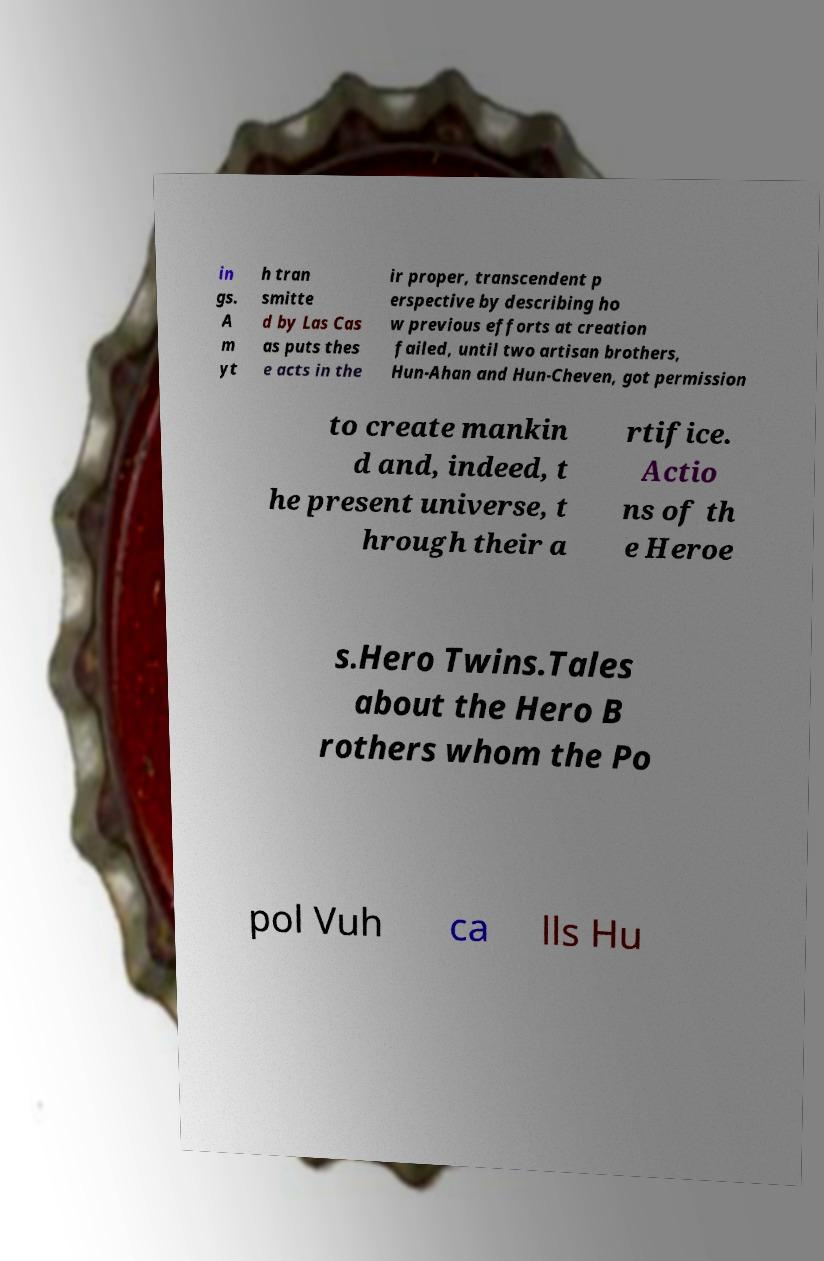Please identify and transcribe the text found in this image. in gs. A m yt h tran smitte d by Las Cas as puts thes e acts in the ir proper, transcendent p erspective by describing ho w previous efforts at creation failed, until two artisan brothers, Hun-Ahan and Hun-Cheven, got permission to create mankin d and, indeed, t he present universe, t hrough their a rtifice. Actio ns of th e Heroe s.Hero Twins.Tales about the Hero B rothers whom the Po pol Vuh ca lls Hu 